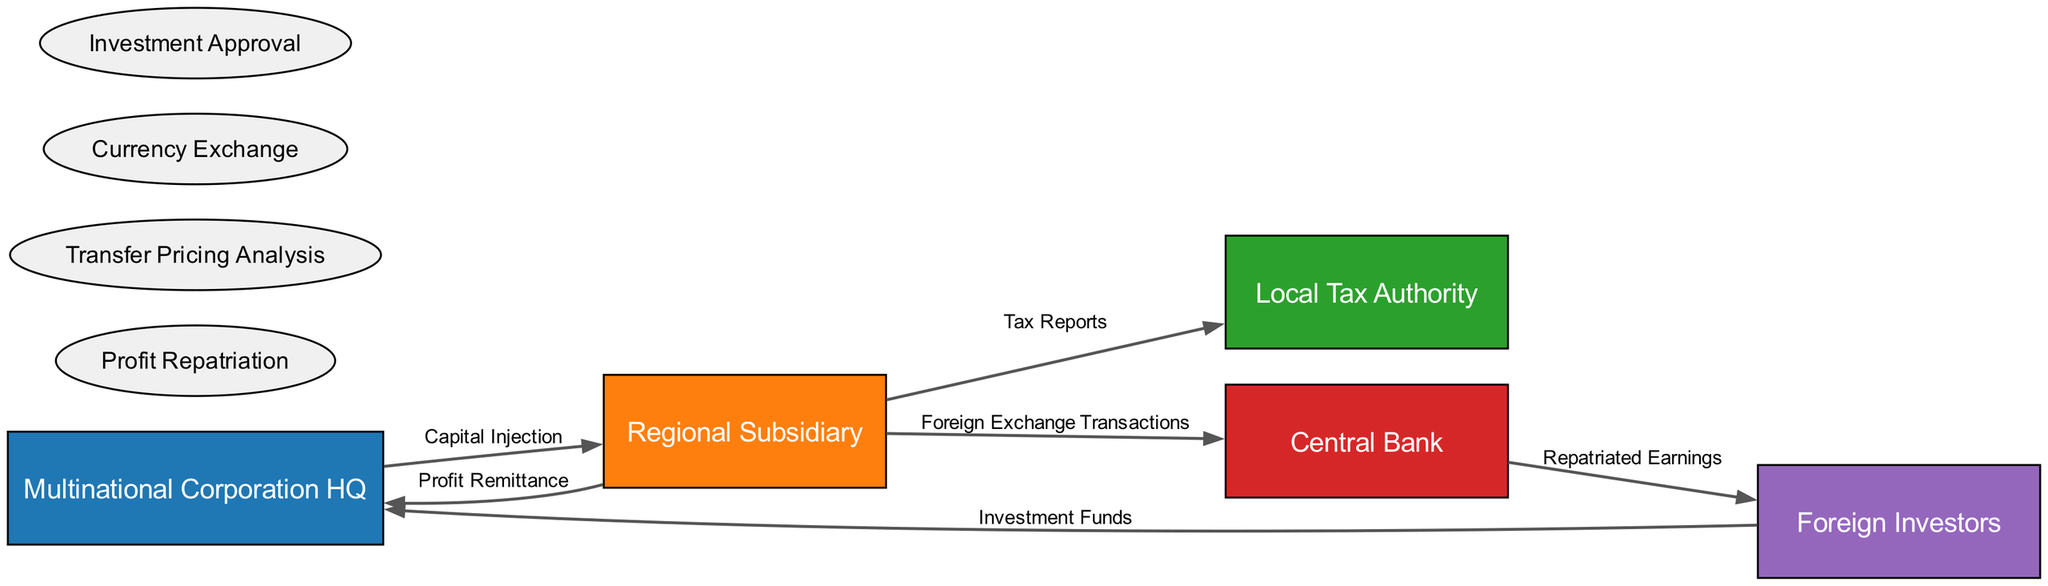What is the number of entities in the diagram? There are five entities listed in the diagram: Multinational Corporation HQ, Regional Subsidiary, Local Tax Authority, Central Bank, and Foreign Investors. Counting these gives us a total of five entities.
Answer: 5 What flow does the Regional Subsidiary send to the Local Tax Authority? The flow labeled "Tax Reports" is sent from the Regional Subsidiary to the Local Tax Authority. This can be verified by checking the data flows originating from the Regional Subsidiary.
Answer: Tax Reports Which entity receives "Investment Funds"? The entity that receives "Investment Funds" is the Multinational Corporation HQ. This is found directly in the data flow from Foreign Investors to Multinational Corporation HQ, labeled as "Investment Funds".
Answer: Multinational Corporation HQ How many processes are shown in the diagram? There are four processes indicated in the diagram: Profit Repatriation, Transfer Pricing Analysis, Currency Exchange, and Investment Approval. Counting these shows a total of four different processes in the flow analysis.
Answer: 4 What is sent from the Regional Subsidiary to the Central Bank? The flow labeled "Foreign Exchange Transactions" is sent from the Regional Subsidiary to the Central Bank. This information can be gathered by looking at the specific data flow descriptions related to the Regional Subsidiary.
Answer: Foreign Exchange Transactions What kind of data flow is indicated between the Central Bank and Foreign Investors? The data flow between the Central Bank and Foreign Investors is labeled "Repatriated Earnings". This indicates the type of information being exchanged in this segment of the diagram.
Answer: Repatriated Earnings Which entity is involved in both profit remittance and capital injection? The Regional Subsidiary is the entity involved in both profit remittance (to Multinational Corporation HQ) and capital injection (from Multinational Corporation HQ). This can be determined by reviewing the data flows connected to the Regional Subsidiary.
Answer: Regional Subsidiary What input does the Foreign Investors provide to the Multinational Corporation HQ? The input provided by Foreign Investors to the Multinational Corporation HQ is "Investment Funds". This is clear from the data flow that shows this relationship between the two entities.
Answer: Investment Funds 